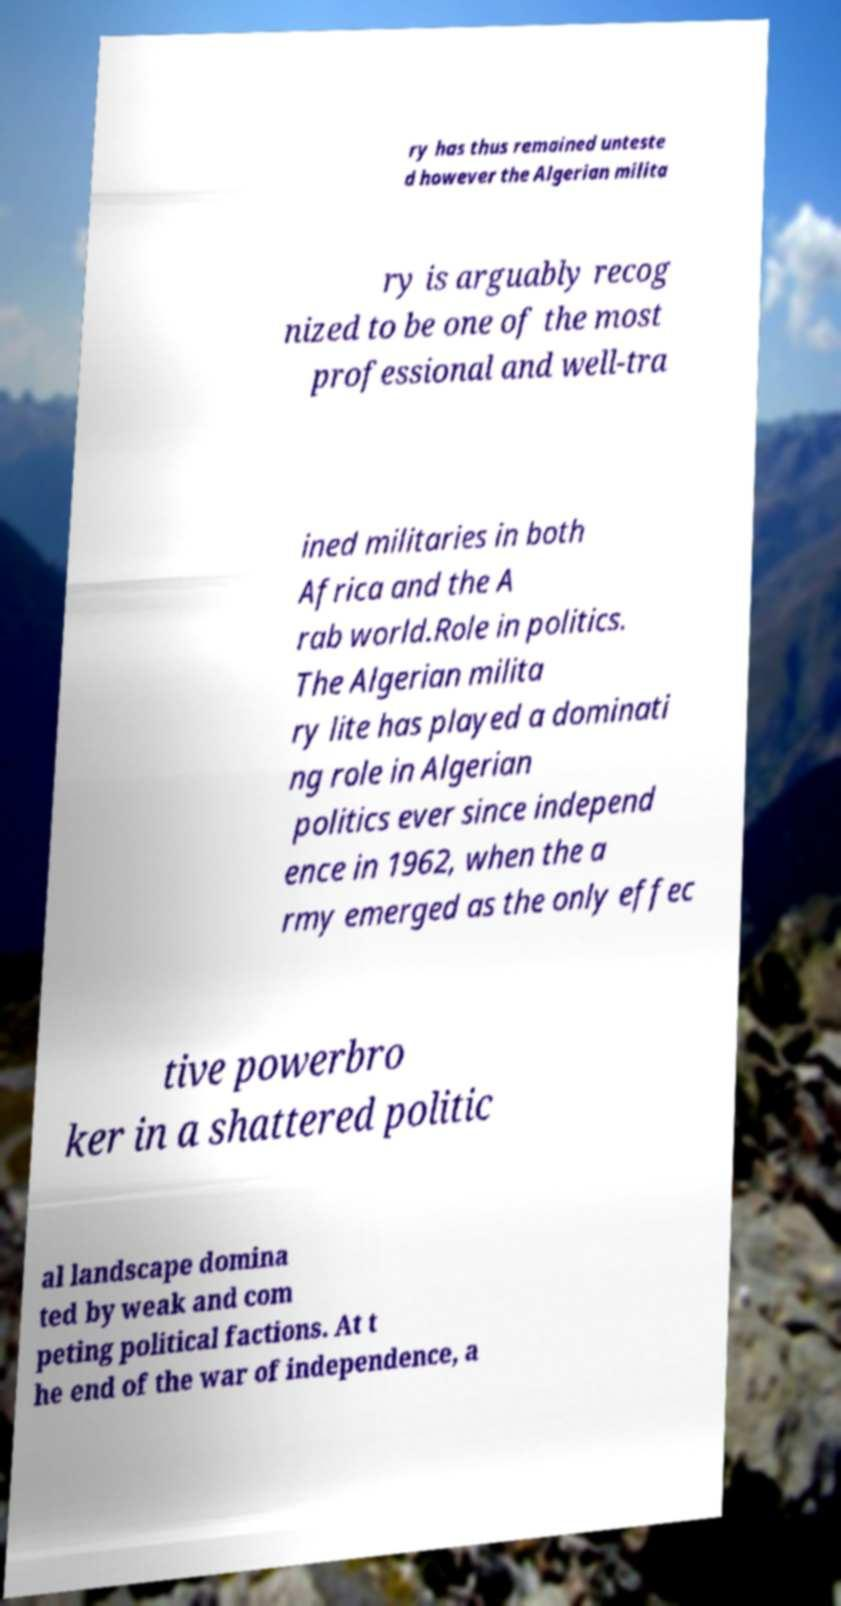For documentation purposes, I need the text within this image transcribed. Could you provide that? ry has thus remained unteste d however the Algerian milita ry is arguably recog nized to be one of the most professional and well-tra ined militaries in both Africa and the A rab world.Role in politics. The Algerian milita ry lite has played a dominati ng role in Algerian politics ever since independ ence in 1962, when the a rmy emerged as the only effec tive powerbro ker in a shattered politic al landscape domina ted by weak and com peting political factions. At t he end of the war of independence, a 